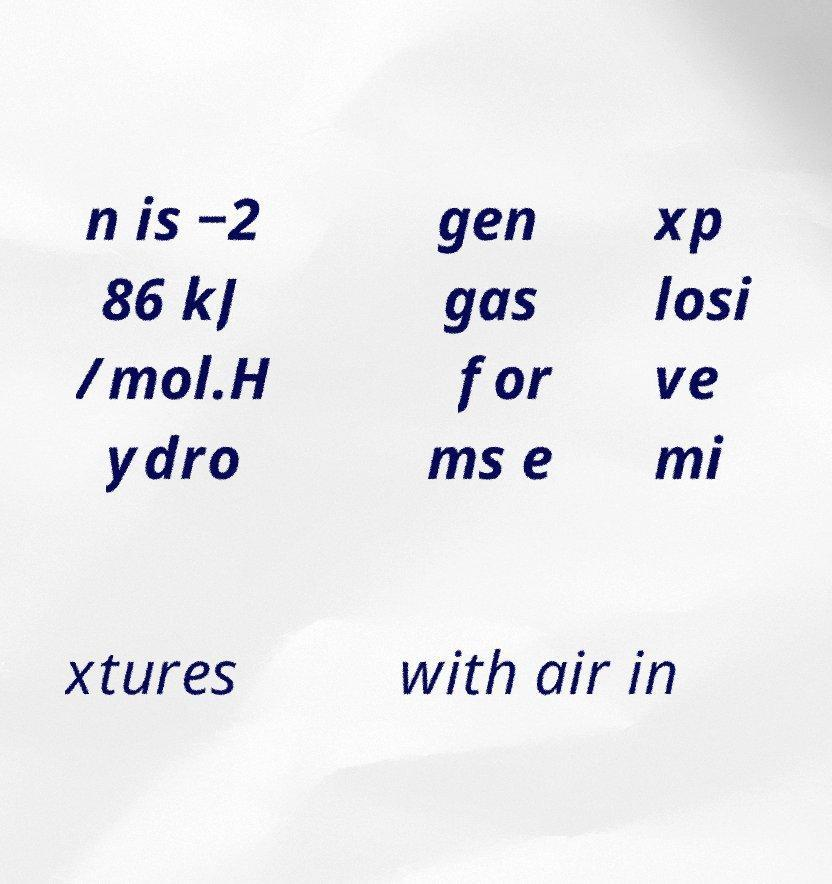Could you assist in decoding the text presented in this image and type it out clearly? n is −2 86 kJ /mol.H ydro gen gas for ms e xp losi ve mi xtures with air in 